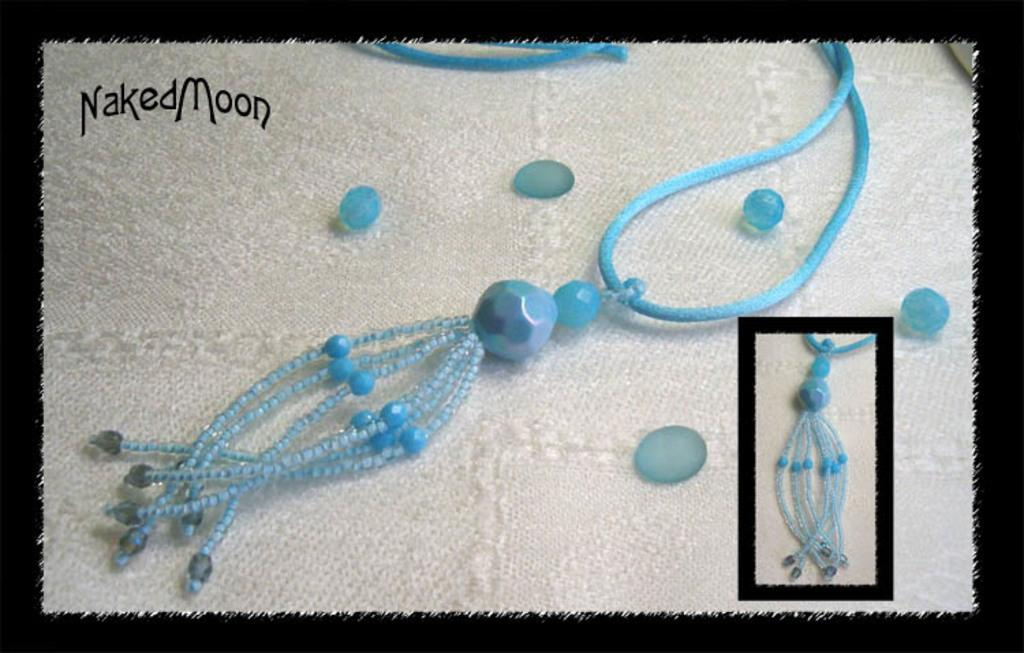What type of image is shown in the collage? The image is a collage. What is the background of the collage? There is a white surface in the image. What items can be seen on the white surface? Jewelries and beads are present on the white surface. Can you see anyone smiling in the image? There are no people present in the image, so it is not possible to see anyone smiling. 